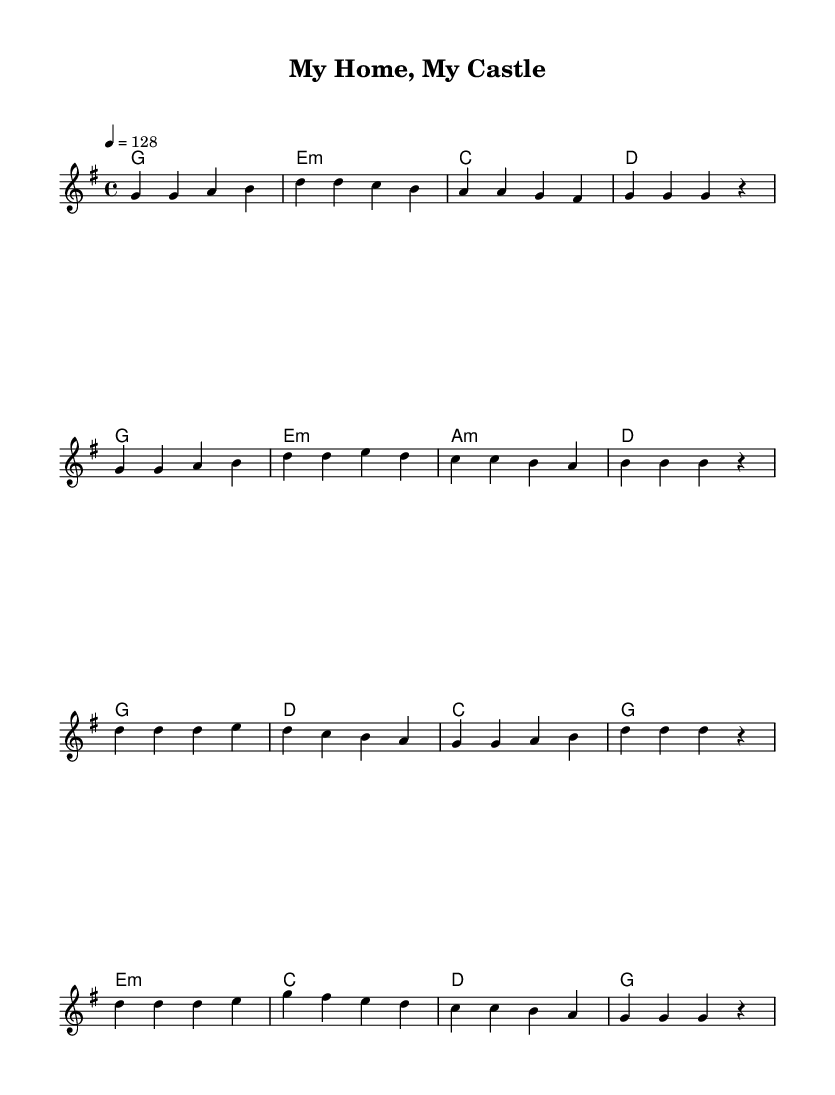What is the key signature of this music? The key signature is G major, which has one sharp (F#). The key signature is typically indicated at the beginning of the staff, where it shows the sharp symbols.
Answer: G major What is the time signature of this music? The time signature is 4/4, which means there are four beats in a measure, and the quarter note gets one beat. This is usually displayed at the beginning of the score, near the key signature.
Answer: 4/4 What is the tempo marking for this piece? The tempo marking is 128 beats per minute, indicated by the number above the score. Tempo markings help performers understand the intended speed of the piece.
Answer: 128 How many measures are in the verse section? The verse consists of 8 measures, which can be counted by looking at the vertical lines that separate each measure in the notation. The total from the verse section confirms this count.
Answer: 8 In what section does the phrase "My home, my castle" appear? This phrase appears in the chorus section, which is identified by the placement of lyrics and the musical structure that follows the verse. It is directly linked to the corresponding melody notes in the score.
Answer: Chorus What type of harmony is used in the verse? The harmony used in the verse features mostly triads, evident from the chord names specified and the format of the chords displayed above the staff, indicating simple major and minor chords.
Answer: Triads How does the melody of the chorus differ from the verse? The melody of the chorus features higher pitches and a more energetic rhythm compared to the verse, which has a more relaxed melodic line; this contrast is typical in musical structures and enhances the celebratory feeling of the chorus.
Answer: Higher pitches 